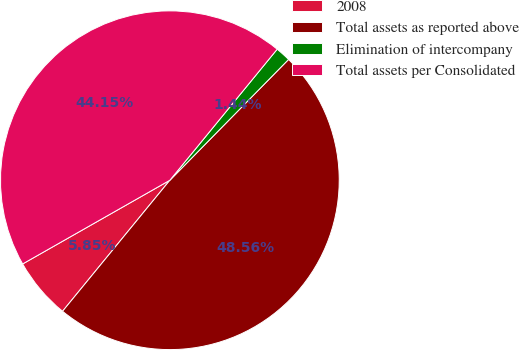Convert chart to OTSL. <chart><loc_0><loc_0><loc_500><loc_500><pie_chart><fcel>2008<fcel>Total assets as reported above<fcel>Elimination of intercompany<fcel>Total assets per Consolidated<nl><fcel>5.85%<fcel>48.56%<fcel>1.44%<fcel>44.15%<nl></chart> 